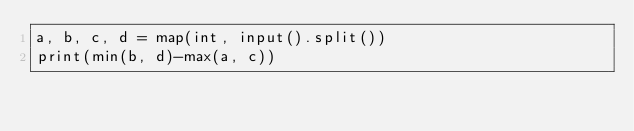<code> <loc_0><loc_0><loc_500><loc_500><_Python_>a, b, c, d = map(int, input().split())
print(min(b, d)-max(a, c))</code> 